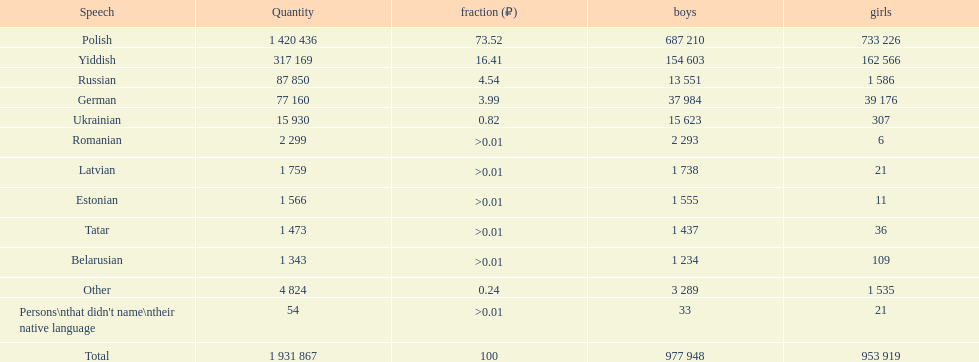Which language had the least female speakers? Romanian. 